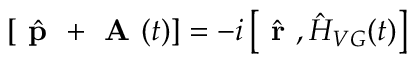<formula> <loc_0><loc_0><loc_500><loc_500>\left [ \hat { p } + A ( t ) \right ] = - i \left [ \hat { r } , \hat { H } _ { V G } ( t ) \right ]</formula> 